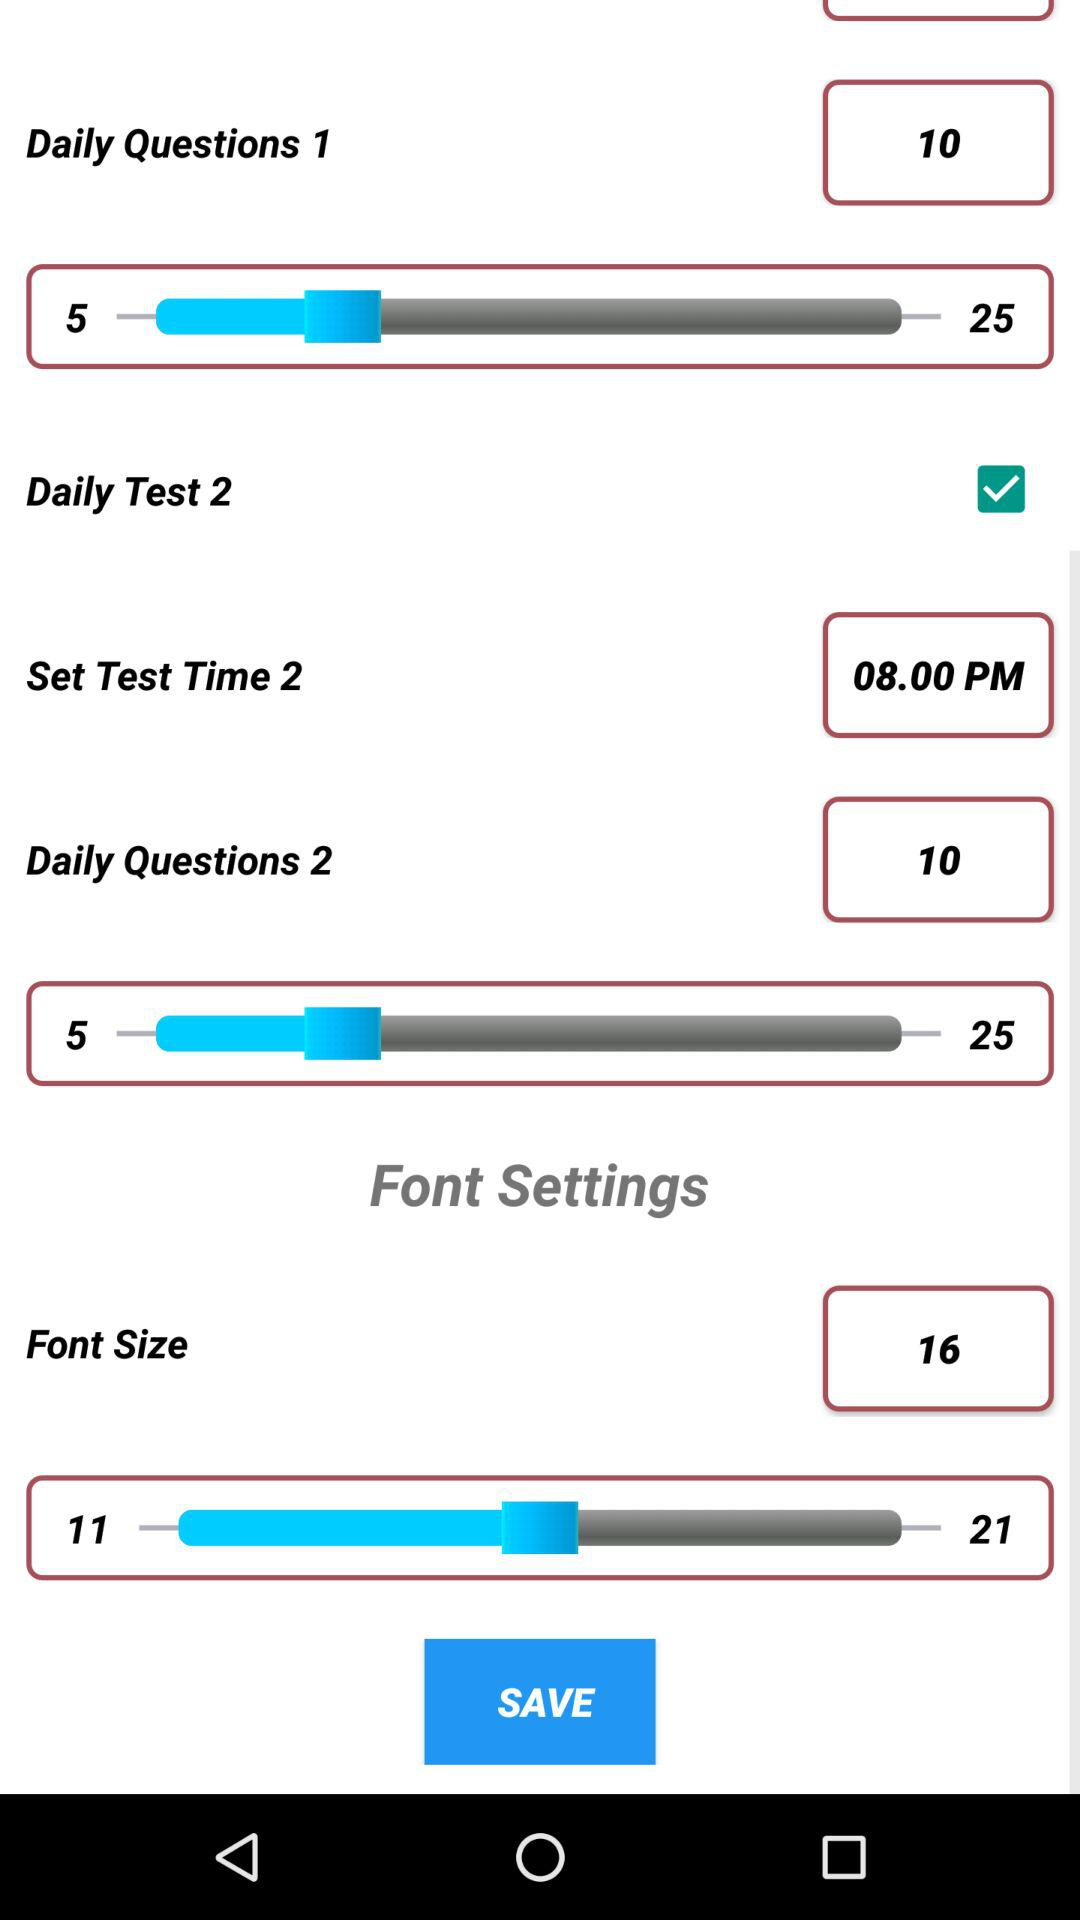What is the status of the "Daily Test 2"? The status is "on". 